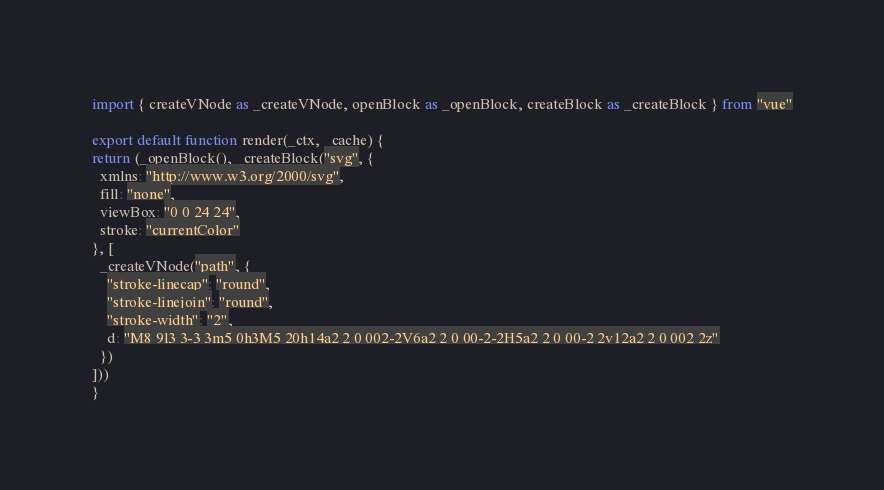Convert code to text. <code><loc_0><loc_0><loc_500><loc_500><_JavaScript_>import { createVNode as _createVNode, openBlock as _openBlock, createBlock as _createBlock } from "vue"

export default function render(_ctx, _cache) {
return (_openBlock(), _createBlock("svg", {
  xmlns: "http://www.w3.org/2000/svg",
  fill: "none",
  viewBox: "0 0 24 24",
  stroke: "currentColor"
}, [
  _createVNode("path", {
    "stroke-linecap": "round",
    "stroke-linejoin": "round",
    "stroke-width": "2",
    d: "M8 9l3 3-3 3m5 0h3M5 20h14a2 2 0 002-2V6a2 2 0 00-2-2H5a2 2 0 00-2 2v12a2 2 0 002 2z"
  })
]))
}</code> 